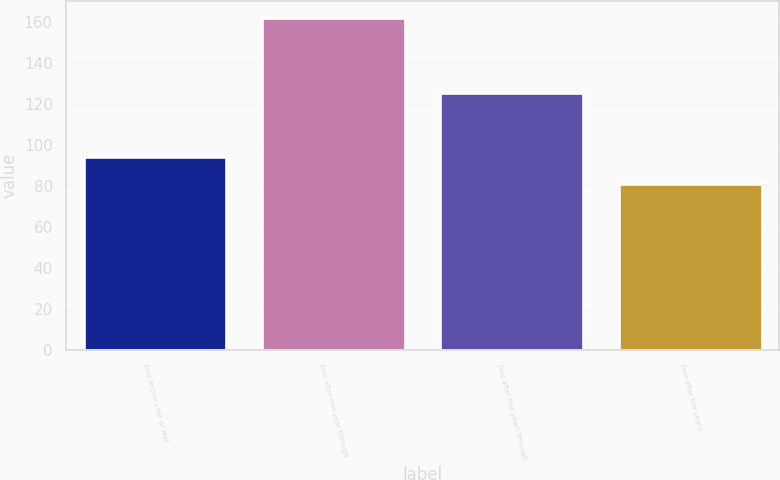Convert chart to OTSL. <chart><loc_0><loc_0><loc_500><loc_500><bar_chart><fcel>Due in one year or less<fcel>Due after one year through<fcel>Due after five years through<fcel>Due after ten years<nl><fcel>94<fcel>162<fcel>125<fcel>81<nl></chart> 